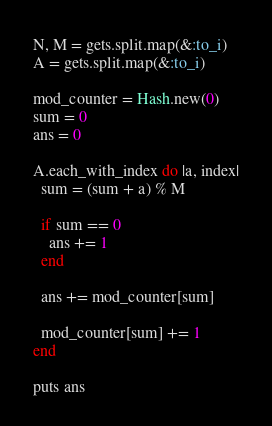Convert code to text. <code><loc_0><loc_0><loc_500><loc_500><_Ruby_>N, M = gets.split.map(&:to_i)
A = gets.split.map(&:to_i)

mod_counter = Hash.new(0)
sum = 0
ans = 0

A.each_with_index do |a, index|
  sum = (sum + a) % M

  if sum == 0
    ans += 1
  end

  ans += mod_counter[sum]

  mod_counter[sum] += 1
end

puts ans
</code> 